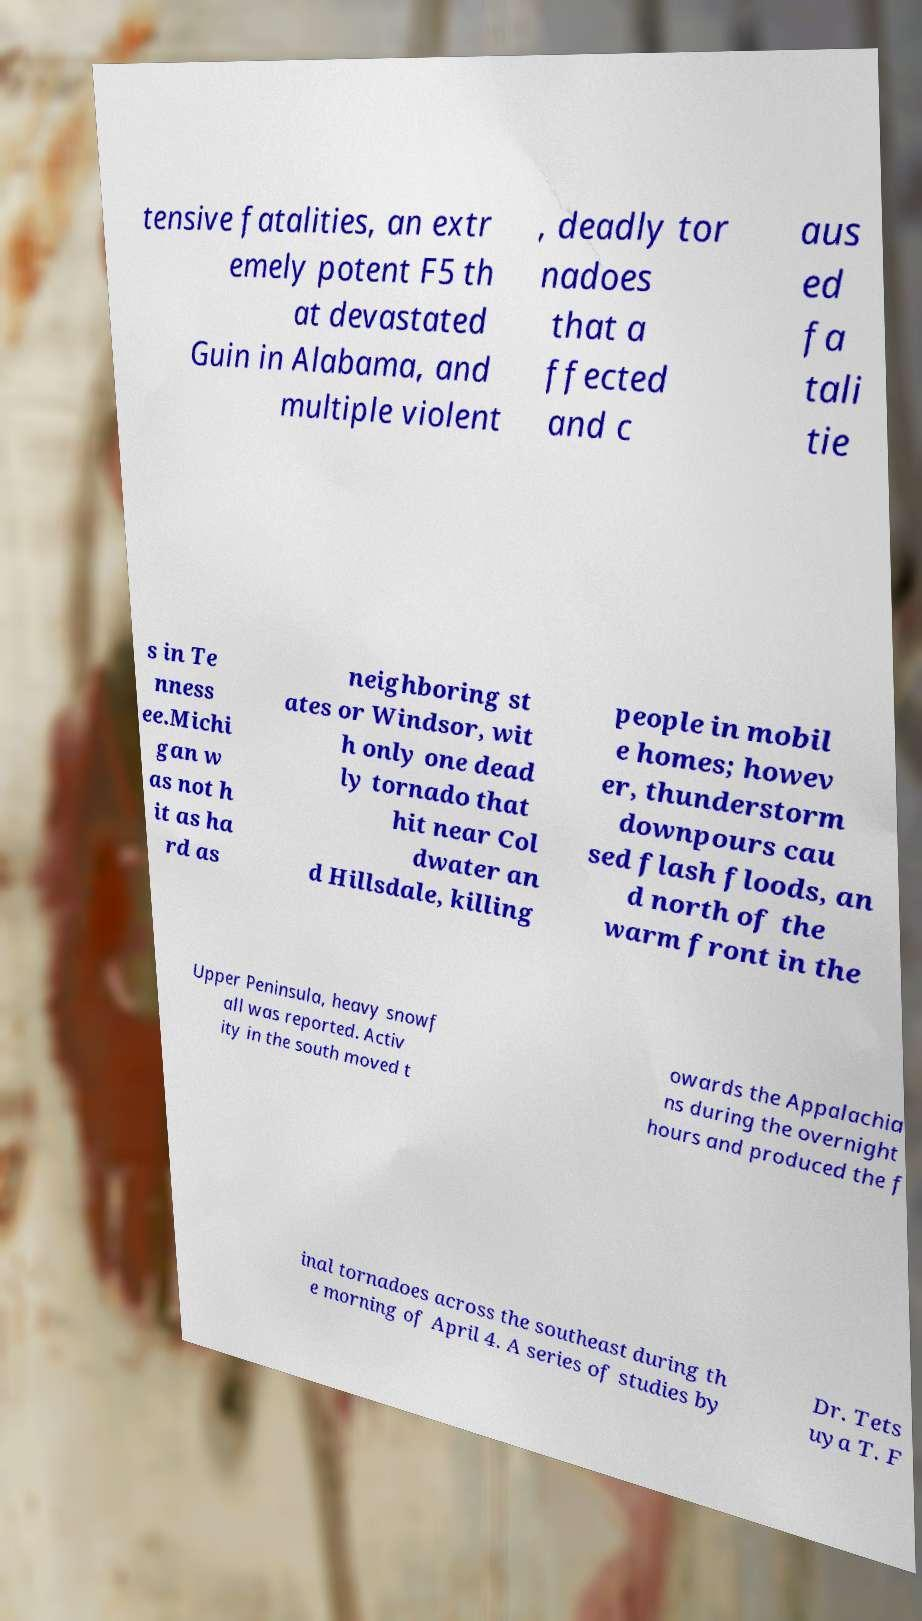Could you assist in decoding the text presented in this image and type it out clearly? tensive fatalities, an extr emely potent F5 th at devastated Guin in Alabama, and multiple violent , deadly tor nadoes that a ffected and c aus ed fa tali tie s in Te nness ee.Michi gan w as not h it as ha rd as neighboring st ates or Windsor, wit h only one dead ly tornado that hit near Col dwater an d Hillsdale, killing people in mobil e homes; howev er, thunderstorm downpours cau sed flash floods, an d north of the warm front in the Upper Peninsula, heavy snowf all was reported. Activ ity in the south moved t owards the Appalachia ns during the overnight hours and produced the f inal tornadoes across the southeast during th e morning of April 4. A series of studies by Dr. Tets uya T. F 